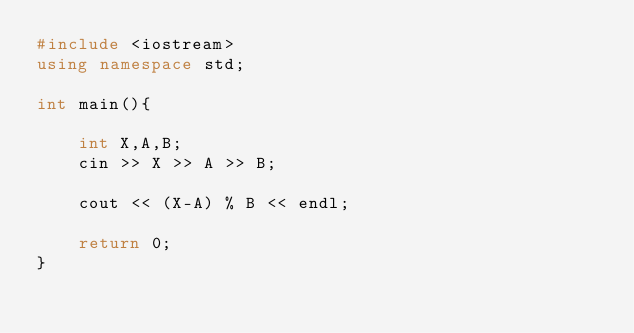<code> <loc_0><loc_0><loc_500><loc_500><_C++_>#include <iostream>
using namespace std;

int main(){

    int X,A,B;
    cin >> X >> A >> B;

    cout << (X-A) % B << endl;
    
    return 0;
}</code> 